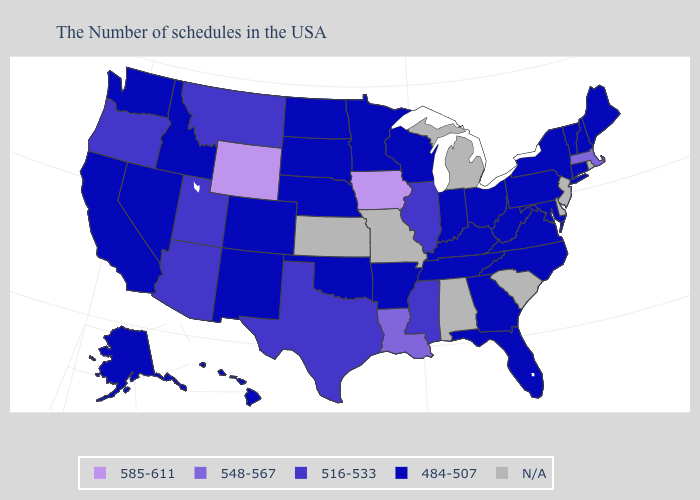What is the value of Texas?
Give a very brief answer. 516-533. Name the states that have a value in the range 484-507?
Write a very short answer. Maine, New Hampshire, Vermont, Connecticut, New York, Maryland, Pennsylvania, Virginia, North Carolina, West Virginia, Ohio, Florida, Georgia, Kentucky, Indiana, Tennessee, Wisconsin, Arkansas, Minnesota, Nebraska, Oklahoma, South Dakota, North Dakota, Colorado, New Mexico, Idaho, Nevada, California, Washington, Alaska, Hawaii. Name the states that have a value in the range 484-507?
Quick response, please. Maine, New Hampshire, Vermont, Connecticut, New York, Maryland, Pennsylvania, Virginia, North Carolina, West Virginia, Ohio, Florida, Georgia, Kentucky, Indiana, Tennessee, Wisconsin, Arkansas, Minnesota, Nebraska, Oklahoma, South Dakota, North Dakota, Colorado, New Mexico, Idaho, Nevada, California, Washington, Alaska, Hawaii. Among the states that border Washington , which have the lowest value?
Answer briefly. Idaho. Name the states that have a value in the range 516-533?
Write a very short answer. Illinois, Mississippi, Texas, Utah, Montana, Arizona, Oregon. Is the legend a continuous bar?
Write a very short answer. No. Name the states that have a value in the range 516-533?
Keep it brief. Illinois, Mississippi, Texas, Utah, Montana, Arizona, Oregon. Name the states that have a value in the range 585-611?
Be succinct. Iowa, Wyoming. Name the states that have a value in the range N/A?
Short answer required. Rhode Island, New Jersey, Delaware, South Carolina, Michigan, Alabama, Missouri, Kansas. Does the first symbol in the legend represent the smallest category?
Answer briefly. No. What is the lowest value in the USA?
Give a very brief answer. 484-507. Name the states that have a value in the range 516-533?
Give a very brief answer. Illinois, Mississippi, Texas, Utah, Montana, Arizona, Oregon. Among the states that border California , which have the highest value?
Write a very short answer. Arizona, Oregon. Name the states that have a value in the range N/A?
Answer briefly. Rhode Island, New Jersey, Delaware, South Carolina, Michigan, Alabama, Missouri, Kansas. Name the states that have a value in the range 484-507?
Quick response, please. Maine, New Hampshire, Vermont, Connecticut, New York, Maryland, Pennsylvania, Virginia, North Carolina, West Virginia, Ohio, Florida, Georgia, Kentucky, Indiana, Tennessee, Wisconsin, Arkansas, Minnesota, Nebraska, Oklahoma, South Dakota, North Dakota, Colorado, New Mexico, Idaho, Nevada, California, Washington, Alaska, Hawaii. 